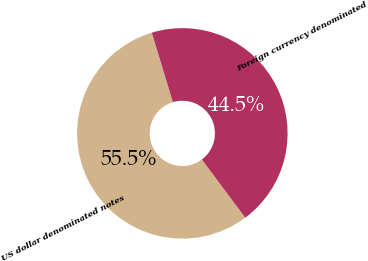Convert chart to OTSL. <chart><loc_0><loc_0><loc_500><loc_500><pie_chart><fcel>US dollar denominated notes<fcel>Foreign currency denominated<nl><fcel>55.52%<fcel>44.48%<nl></chart> 